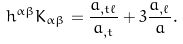<formula> <loc_0><loc_0><loc_500><loc_500>h ^ { \alpha \beta } K _ { \alpha \beta } = \frac { a _ { , t \ell } } { a _ { , t } } + 3 \frac { a _ { , \ell } } { a } .</formula> 